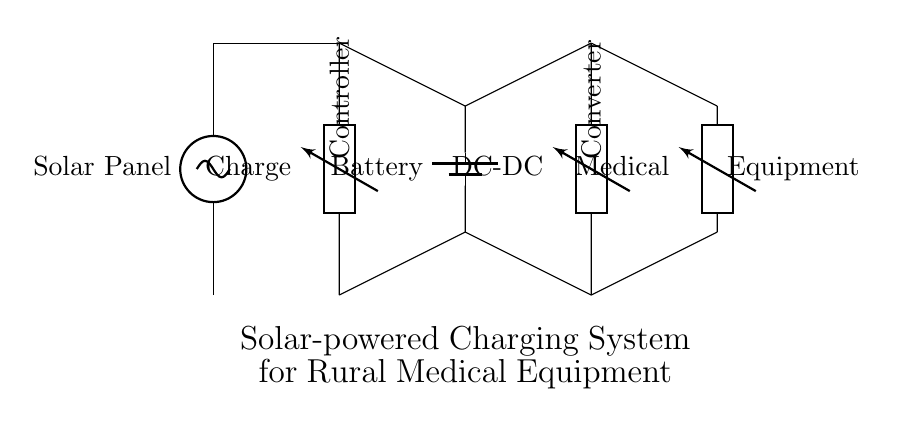What components are present in this circuit? The circuit consists of a solar panel, charge controller, battery, DC-DC converter, and medical equipment. Each component serves a specific function in the charging system.
Answer: solar panel, charge controller, battery, DC-DC converter, medical equipment What is the purpose of the charge controller? The charge controller regulates the voltage and current coming from the solar panel to protect the battery from overcharging. This is a critical function in solar-powered systems to ensure battery longevity.
Answer: regulate voltage and current Which component is responsible for storing energy? The battery is the component that stores electrical energy generated by the solar panel for later use by the medical equipment. It acts as an energy reservoir.
Answer: battery How is the solar energy converted for use in medical equipment? The solar energy is first captured by the solar panel, then converted to a suitable voltage by the DC-DC converter, making it usable for the medical equipment. This series of components allows for efficient energy transformation and delivery.
Answer: through DC-DC converter Which components are connected directly to the battery? The charge controller and the DC-DC converter are directly connected to the battery. The charge controller manages the energy coming in from the solar panel, while the DC-DC converter chips away at the battery's stored energy for the equipment.
Answer: charge controller, DC-DC converter What would happen if the charge controller failed? If the charge controller fails, it may lead to overcharging the battery, which can cause damage or failure of the battery. Additionally, there may be unregulated voltage supplied to the medical equipment, risking equipment damage.
Answer: potential battery damage What voltage does the solar panel provide? The circuit diagram does not specify an exact voltage for the solar panel; however, typically, solar panels output voltages ranging from 12V to 24V, depending on the design and configuration. This aspect must be considered when designing a system.
Answer: unspecified, typically 12V-24V 